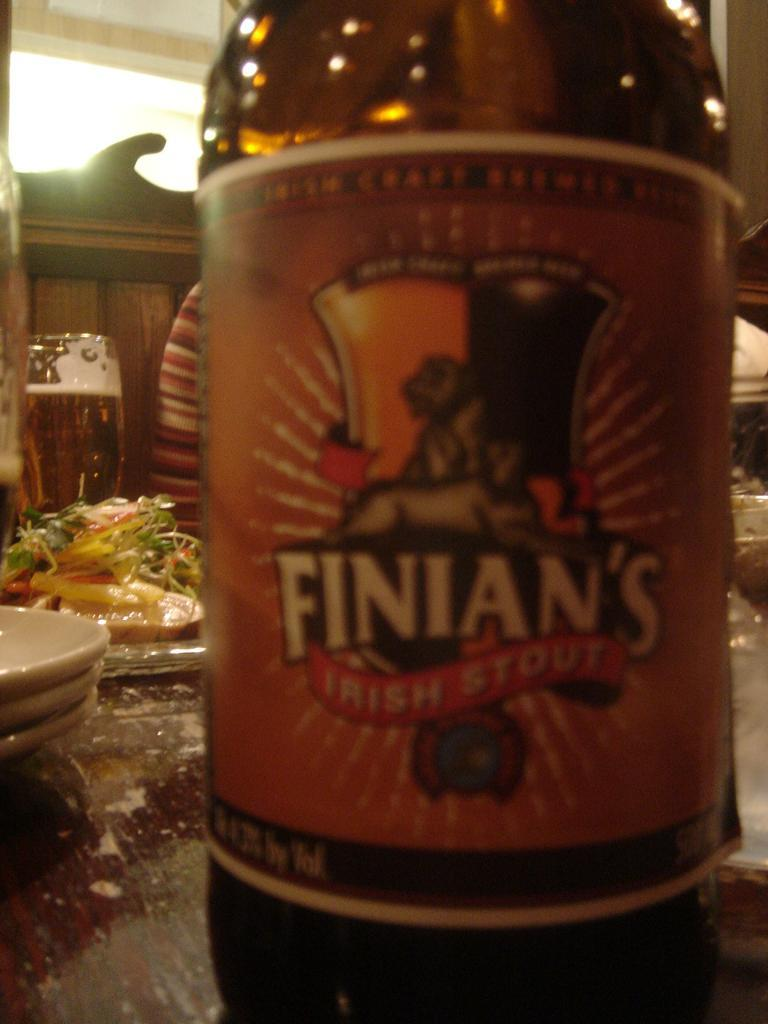What is present on the table in the image? There are plates on the table in the image. What else can be seen on the table besides the plates? There is a bottle and a glass with a drink in the image. What type of company is depicted on the railway in the image? There is no railway or company present in the image. 